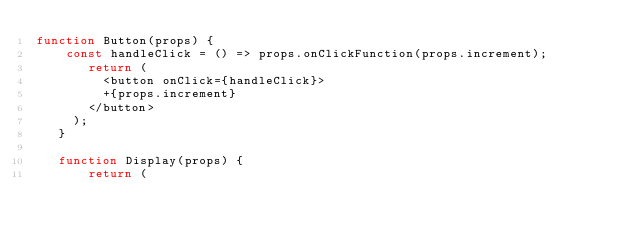<code> <loc_0><loc_0><loc_500><loc_500><_JavaScript_>function Button(props) {
    const handleClick = () => props.onClickFunction(props.increment);
       return (
         <button onClick={handleClick}>
         +{props.increment}
       </button>
     );
   }
   
   function Display(props) {
       return (</code> 